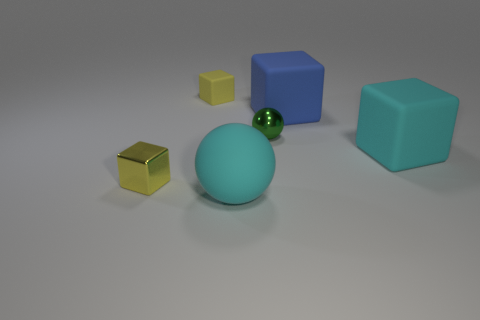Subtract all large blue cubes. How many cubes are left? 3 Subtract all cubes. How many objects are left? 2 Add 2 metal things. How many objects exist? 8 Subtract 2 spheres. How many spheres are left? 0 Subtract all yellow blocks. How many blocks are left? 2 Subtract all metallic balls. Subtract all large objects. How many objects are left? 2 Add 3 spheres. How many spheres are left? 5 Add 2 large spheres. How many large spheres exist? 3 Subtract 1 cyan blocks. How many objects are left? 5 Subtract all green spheres. Subtract all green cylinders. How many spheres are left? 1 